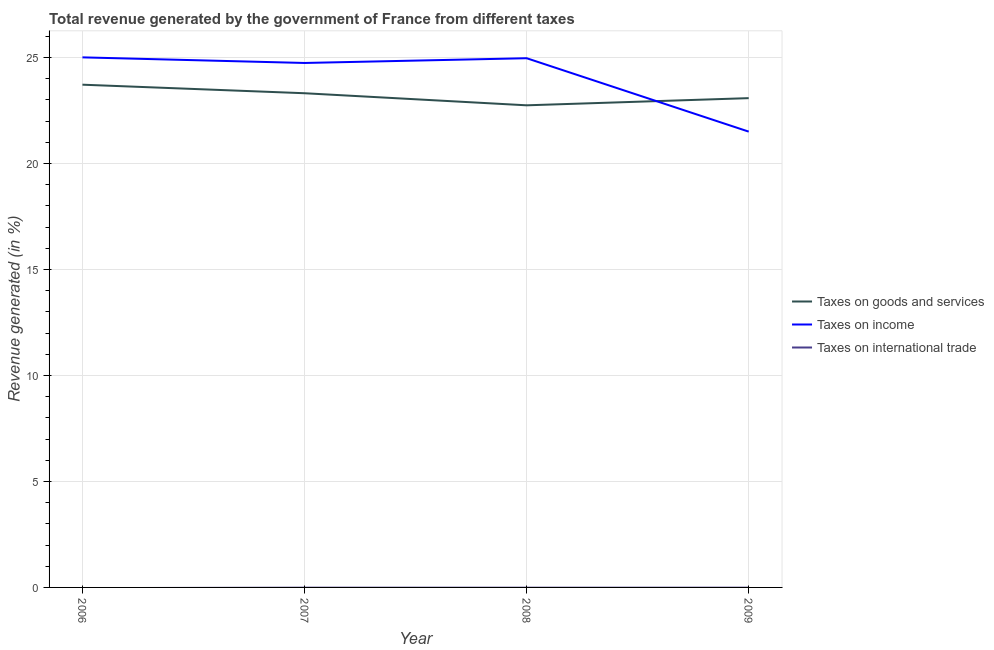Is the number of lines equal to the number of legend labels?
Provide a short and direct response. No. What is the percentage of revenue generated by taxes on income in 2007?
Make the answer very short. 24.74. Across all years, what is the maximum percentage of revenue generated by taxes on goods and services?
Provide a short and direct response. 23.72. Across all years, what is the minimum percentage of revenue generated by taxes on income?
Keep it short and to the point. 21.5. In which year was the percentage of revenue generated by taxes on income maximum?
Make the answer very short. 2006. What is the total percentage of revenue generated by taxes on income in the graph?
Give a very brief answer. 96.22. What is the difference between the percentage of revenue generated by taxes on goods and services in 2006 and that in 2009?
Make the answer very short. 0.63. What is the difference between the percentage of revenue generated by taxes on goods and services in 2007 and the percentage of revenue generated by tax on international trade in 2009?
Your response must be concise. 23.32. What is the average percentage of revenue generated by tax on international trade per year?
Offer a very short reply. 0. In the year 2009, what is the difference between the percentage of revenue generated by taxes on goods and services and percentage of revenue generated by taxes on income?
Give a very brief answer. 1.58. In how many years, is the percentage of revenue generated by tax on international trade greater than 2 %?
Your response must be concise. 0. What is the ratio of the percentage of revenue generated by taxes on income in 2006 to that in 2009?
Make the answer very short. 1.16. Is the percentage of revenue generated by taxes on goods and services in 2008 less than that in 2009?
Your answer should be compact. Yes. Is the difference between the percentage of revenue generated by taxes on goods and services in 2006 and 2007 greater than the difference between the percentage of revenue generated by taxes on income in 2006 and 2007?
Provide a succinct answer. Yes. What is the difference between the highest and the second highest percentage of revenue generated by taxes on income?
Offer a very short reply. 0.04. What is the difference between the highest and the lowest percentage of revenue generated by taxes on goods and services?
Your answer should be compact. 0.97. In how many years, is the percentage of revenue generated by taxes on income greater than the average percentage of revenue generated by taxes on income taken over all years?
Your response must be concise. 3. Is it the case that in every year, the sum of the percentage of revenue generated by taxes on goods and services and percentage of revenue generated by taxes on income is greater than the percentage of revenue generated by tax on international trade?
Make the answer very short. Yes. Does the percentage of revenue generated by taxes on income monotonically increase over the years?
Provide a succinct answer. No. Is the percentage of revenue generated by taxes on goods and services strictly less than the percentage of revenue generated by taxes on income over the years?
Provide a succinct answer. No. How many lines are there?
Your response must be concise. 2. How many years are there in the graph?
Your answer should be compact. 4. What is the difference between two consecutive major ticks on the Y-axis?
Provide a succinct answer. 5. Does the graph contain any zero values?
Provide a succinct answer. Yes. Does the graph contain grids?
Make the answer very short. Yes. What is the title of the graph?
Keep it short and to the point. Total revenue generated by the government of France from different taxes. Does "Industrial Nitrous Oxide" appear as one of the legend labels in the graph?
Ensure brevity in your answer.  No. What is the label or title of the Y-axis?
Keep it short and to the point. Revenue generated (in %). What is the Revenue generated (in %) of Taxes on goods and services in 2006?
Offer a very short reply. 23.72. What is the Revenue generated (in %) of Taxes on income in 2006?
Ensure brevity in your answer.  25.01. What is the Revenue generated (in %) of Taxes on goods and services in 2007?
Make the answer very short. 23.32. What is the Revenue generated (in %) in Taxes on income in 2007?
Give a very brief answer. 24.74. What is the Revenue generated (in %) of Taxes on international trade in 2007?
Ensure brevity in your answer.  0. What is the Revenue generated (in %) of Taxes on goods and services in 2008?
Give a very brief answer. 22.75. What is the Revenue generated (in %) of Taxes on income in 2008?
Provide a short and direct response. 24.97. What is the Revenue generated (in %) in Taxes on goods and services in 2009?
Your response must be concise. 23.08. What is the Revenue generated (in %) of Taxes on income in 2009?
Give a very brief answer. 21.5. What is the Revenue generated (in %) in Taxes on international trade in 2009?
Your answer should be compact. 0. Across all years, what is the maximum Revenue generated (in %) of Taxes on goods and services?
Keep it short and to the point. 23.72. Across all years, what is the maximum Revenue generated (in %) of Taxes on income?
Offer a very short reply. 25.01. Across all years, what is the minimum Revenue generated (in %) of Taxes on goods and services?
Your response must be concise. 22.75. Across all years, what is the minimum Revenue generated (in %) of Taxes on income?
Your response must be concise. 21.5. What is the total Revenue generated (in %) of Taxes on goods and services in the graph?
Offer a terse response. 92.86. What is the total Revenue generated (in %) in Taxes on income in the graph?
Make the answer very short. 96.22. What is the total Revenue generated (in %) in Taxes on international trade in the graph?
Your answer should be very brief. 0. What is the difference between the Revenue generated (in %) in Taxes on goods and services in 2006 and that in 2007?
Provide a succinct answer. 0.4. What is the difference between the Revenue generated (in %) in Taxes on income in 2006 and that in 2007?
Offer a terse response. 0.26. What is the difference between the Revenue generated (in %) of Taxes on goods and services in 2006 and that in 2008?
Ensure brevity in your answer.  0.97. What is the difference between the Revenue generated (in %) of Taxes on income in 2006 and that in 2008?
Provide a short and direct response. 0.04. What is the difference between the Revenue generated (in %) in Taxes on goods and services in 2006 and that in 2009?
Keep it short and to the point. 0.63. What is the difference between the Revenue generated (in %) in Taxes on income in 2006 and that in 2009?
Your response must be concise. 3.5. What is the difference between the Revenue generated (in %) of Taxes on goods and services in 2007 and that in 2008?
Keep it short and to the point. 0.57. What is the difference between the Revenue generated (in %) of Taxes on income in 2007 and that in 2008?
Keep it short and to the point. -0.22. What is the difference between the Revenue generated (in %) in Taxes on goods and services in 2007 and that in 2009?
Ensure brevity in your answer.  0.23. What is the difference between the Revenue generated (in %) of Taxes on income in 2007 and that in 2009?
Provide a succinct answer. 3.24. What is the difference between the Revenue generated (in %) of Taxes on goods and services in 2008 and that in 2009?
Give a very brief answer. -0.34. What is the difference between the Revenue generated (in %) of Taxes on income in 2008 and that in 2009?
Provide a short and direct response. 3.46. What is the difference between the Revenue generated (in %) in Taxes on goods and services in 2006 and the Revenue generated (in %) in Taxes on income in 2007?
Your answer should be compact. -1.02. What is the difference between the Revenue generated (in %) in Taxes on goods and services in 2006 and the Revenue generated (in %) in Taxes on income in 2008?
Offer a terse response. -1.25. What is the difference between the Revenue generated (in %) of Taxes on goods and services in 2006 and the Revenue generated (in %) of Taxes on income in 2009?
Your answer should be very brief. 2.21. What is the difference between the Revenue generated (in %) of Taxes on goods and services in 2007 and the Revenue generated (in %) of Taxes on income in 2008?
Offer a terse response. -1.65. What is the difference between the Revenue generated (in %) in Taxes on goods and services in 2007 and the Revenue generated (in %) in Taxes on income in 2009?
Your answer should be compact. 1.81. What is the difference between the Revenue generated (in %) in Taxes on goods and services in 2008 and the Revenue generated (in %) in Taxes on income in 2009?
Offer a very short reply. 1.24. What is the average Revenue generated (in %) in Taxes on goods and services per year?
Provide a short and direct response. 23.22. What is the average Revenue generated (in %) of Taxes on income per year?
Your response must be concise. 24.06. In the year 2006, what is the difference between the Revenue generated (in %) of Taxes on goods and services and Revenue generated (in %) of Taxes on income?
Your answer should be very brief. -1.29. In the year 2007, what is the difference between the Revenue generated (in %) of Taxes on goods and services and Revenue generated (in %) of Taxes on income?
Keep it short and to the point. -1.43. In the year 2008, what is the difference between the Revenue generated (in %) of Taxes on goods and services and Revenue generated (in %) of Taxes on income?
Ensure brevity in your answer.  -2.22. In the year 2009, what is the difference between the Revenue generated (in %) in Taxes on goods and services and Revenue generated (in %) in Taxes on income?
Your answer should be compact. 1.58. What is the ratio of the Revenue generated (in %) of Taxes on goods and services in 2006 to that in 2007?
Give a very brief answer. 1.02. What is the ratio of the Revenue generated (in %) of Taxes on income in 2006 to that in 2007?
Make the answer very short. 1.01. What is the ratio of the Revenue generated (in %) of Taxes on goods and services in 2006 to that in 2008?
Your response must be concise. 1.04. What is the ratio of the Revenue generated (in %) of Taxes on goods and services in 2006 to that in 2009?
Your answer should be compact. 1.03. What is the ratio of the Revenue generated (in %) in Taxes on income in 2006 to that in 2009?
Your response must be concise. 1.16. What is the ratio of the Revenue generated (in %) in Taxes on goods and services in 2007 to that in 2008?
Provide a short and direct response. 1.03. What is the ratio of the Revenue generated (in %) in Taxes on goods and services in 2007 to that in 2009?
Ensure brevity in your answer.  1.01. What is the ratio of the Revenue generated (in %) in Taxes on income in 2007 to that in 2009?
Give a very brief answer. 1.15. What is the ratio of the Revenue generated (in %) in Taxes on goods and services in 2008 to that in 2009?
Your response must be concise. 0.99. What is the ratio of the Revenue generated (in %) of Taxes on income in 2008 to that in 2009?
Keep it short and to the point. 1.16. What is the difference between the highest and the second highest Revenue generated (in %) in Taxes on goods and services?
Provide a short and direct response. 0.4. What is the difference between the highest and the second highest Revenue generated (in %) of Taxes on income?
Make the answer very short. 0.04. What is the difference between the highest and the lowest Revenue generated (in %) of Taxes on goods and services?
Give a very brief answer. 0.97. What is the difference between the highest and the lowest Revenue generated (in %) in Taxes on income?
Offer a very short reply. 3.5. 